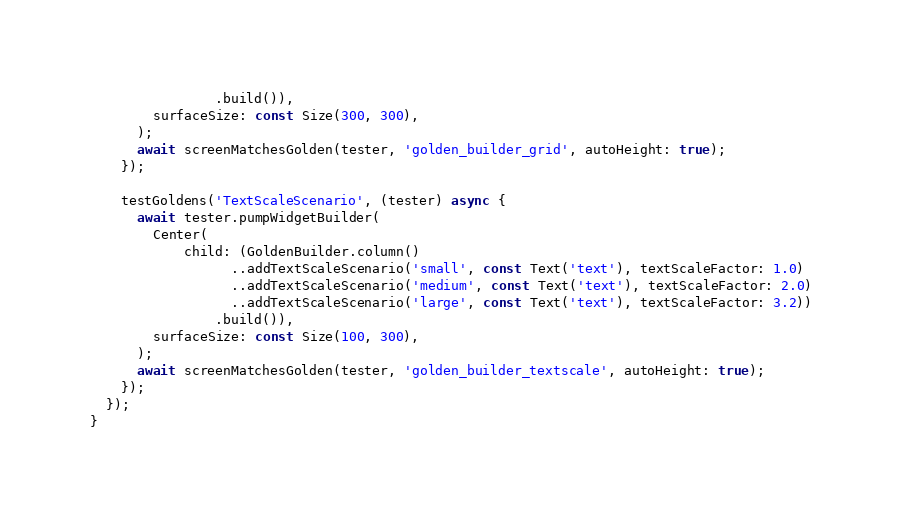Convert code to text. <code><loc_0><loc_0><loc_500><loc_500><_Dart_>                .build()),
        surfaceSize: const Size(300, 300),
      );
      await screenMatchesGolden(tester, 'golden_builder_grid', autoHeight: true);
    });

    testGoldens('TextScaleScenario', (tester) async {
      await tester.pumpWidgetBuilder(
        Center(
            child: (GoldenBuilder.column()
                  ..addTextScaleScenario('small', const Text('text'), textScaleFactor: 1.0)
                  ..addTextScaleScenario('medium', const Text('text'), textScaleFactor: 2.0)
                  ..addTextScaleScenario('large', const Text('text'), textScaleFactor: 3.2))
                .build()),
        surfaceSize: const Size(100, 300),
      );
      await screenMatchesGolden(tester, 'golden_builder_textscale', autoHeight: true);
    });
  });
}
</code> 